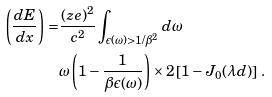Convert formula to latex. <formula><loc_0><loc_0><loc_500><loc_500>\left ( \frac { d E } { d x } \right ) = & \frac { ( z e ) ^ { 2 } } { c ^ { 2 } } \int _ { \epsilon ( \omega ) > 1 / \beta ^ { 2 } } d \omega \\ & \omega \left ( 1 - \frac { 1 } { \beta \epsilon ( \omega ) } \right ) \times 2 \left [ 1 - J _ { 0 } ( \lambda d ) \right ] \, .</formula> 